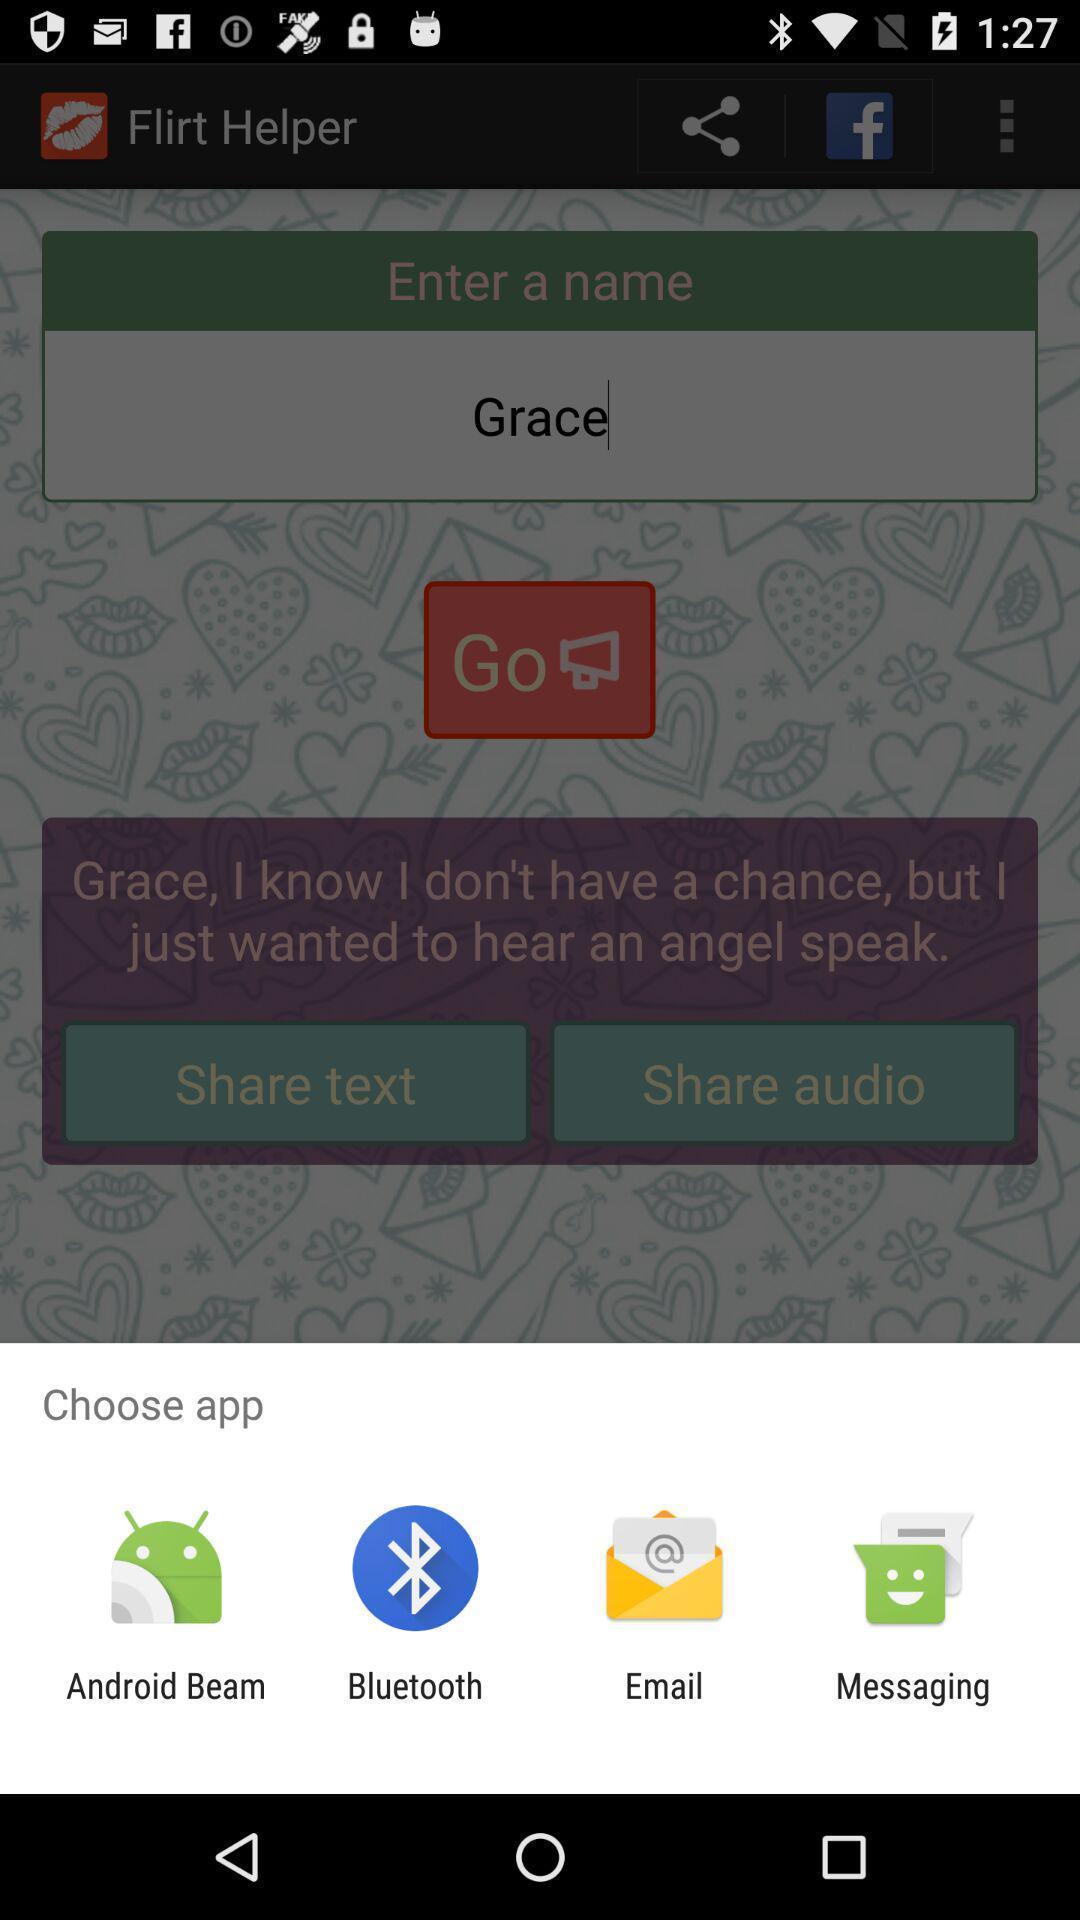Explain what's happening in this screen capture. Popup to choose for the dating app. 